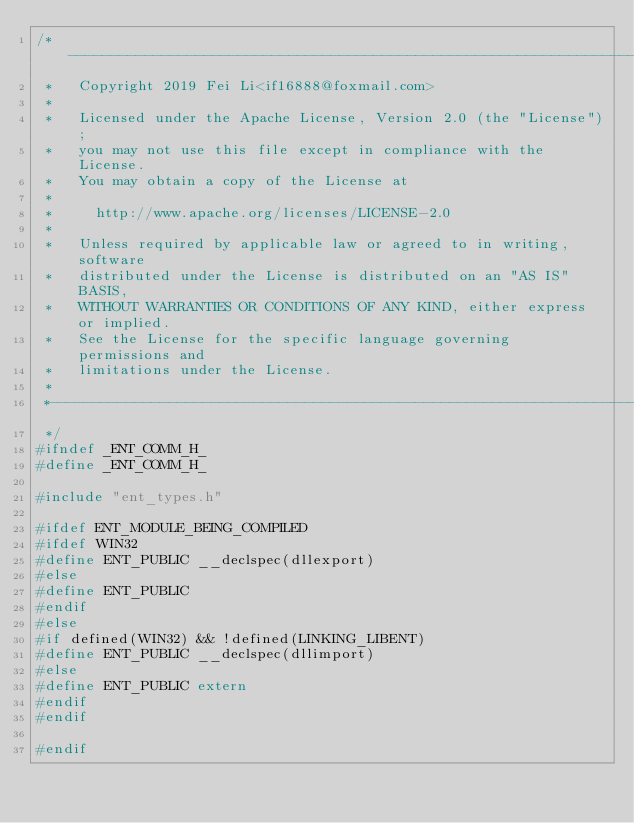Convert code to text. <code><loc_0><loc_0><loc_500><loc_500><_C_>/*-----------------------------------------------------------------------------
 *   Copyright 2019 Fei Li<if16888@foxmail.com>
 * 
 *   Licensed under the Apache License, Version 2.0 (the "License");
 *   you may not use this file except in compliance with the License.
 *   You may obtain a copy of the License at
 * 
 *     http://www.apache.org/licenses/LICENSE-2.0
 * 
 *   Unless required by applicable law or agreed to in writing, software
 *   distributed under the License is distributed on an "AS IS" BASIS,
 *   WITHOUT WARRANTIES OR CONDITIONS OF ANY KIND, either express or implied.
 *   See the License for the specific language governing permissions and
 *   limitations under the License.
 *
 *-----------------------------------------------------------------------------
 */
#ifndef _ENT_COMM_H_
#define _ENT_COMM_H_

#include "ent_types.h"

#ifdef ENT_MODULE_BEING_COMPILED
#ifdef WIN32
#define ENT_PUBLIC __declspec(dllexport)
#else
#define ENT_PUBLIC
#endif
#else
#if defined(WIN32) && !defined(LINKING_LIBENT)
#define ENT_PUBLIC __declspec(dllimport)
#else
#define ENT_PUBLIC extern
#endif
#endif

#endif</code> 